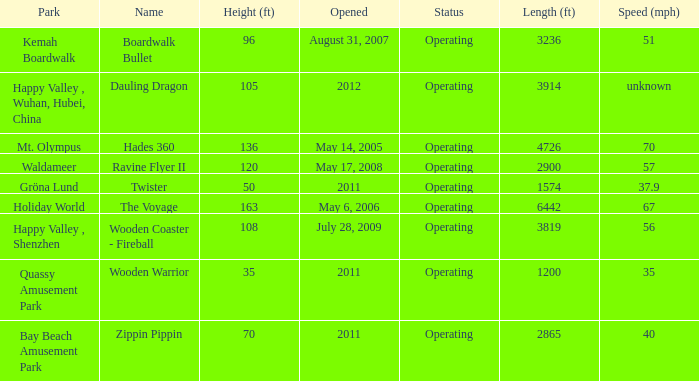How long is the rollar coaster on Kemah Boardwalk 3236.0. 